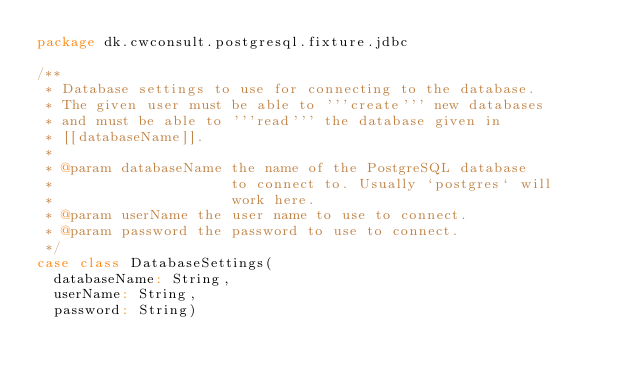<code> <loc_0><loc_0><loc_500><loc_500><_Scala_>package dk.cwconsult.postgresql.fixture.jdbc

/**
 * Database settings to use for connecting to the database.
 * The given user must be able to '''create''' new databases
 * and must be able to '''read''' the database given in
 * [[databaseName]].
 *
 * @param databaseName the name of the PostgreSQL database
 *                     to connect to. Usually `postgres` will
 *                     work here.
 * @param userName the user name to use to connect.
 * @param password the password to use to connect.
 */
case class DatabaseSettings(
  databaseName: String,
  userName: String,
  password: String)
</code> 